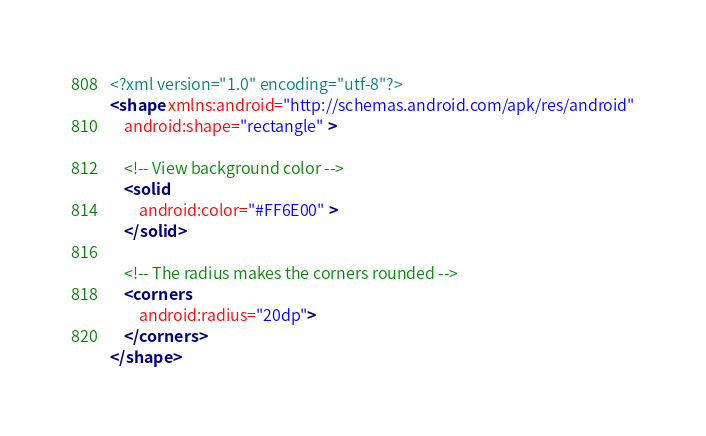<code> <loc_0><loc_0><loc_500><loc_500><_XML_><?xml version="1.0" encoding="utf-8"?>
<shape xmlns:android="http://schemas.android.com/apk/res/android"
    android:shape="rectangle" >

    <!-- View background color -->
    <solid
        android:color="#FF6E00" >
    </solid>

    <!-- The radius makes the corners rounded -->
    <corners
        android:radius="20dp">
    </corners>
</shape>
</code> 